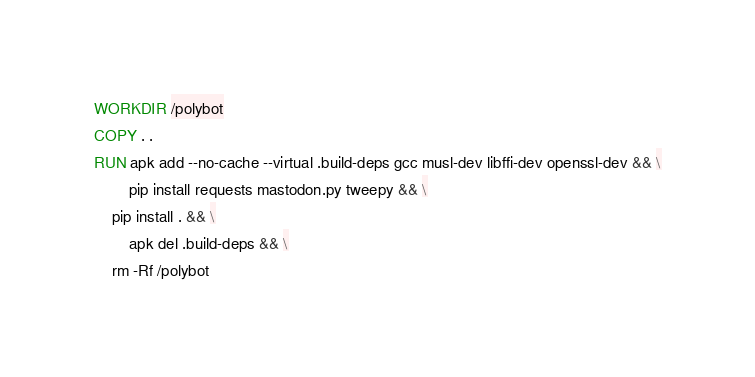<code> <loc_0><loc_0><loc_500><loc_500><_Dockerfile_>WORKDIR /polybot
COPY . .
RUN apk add --no-cache --virtual .build-deps gcc musl-dev libffi-dev openssl-dev && \
        pip install requests mastodon.py tweepy && \
	pip install . && \
        apk del .build-deps && \
	rm -Rf /polybot
</code> 